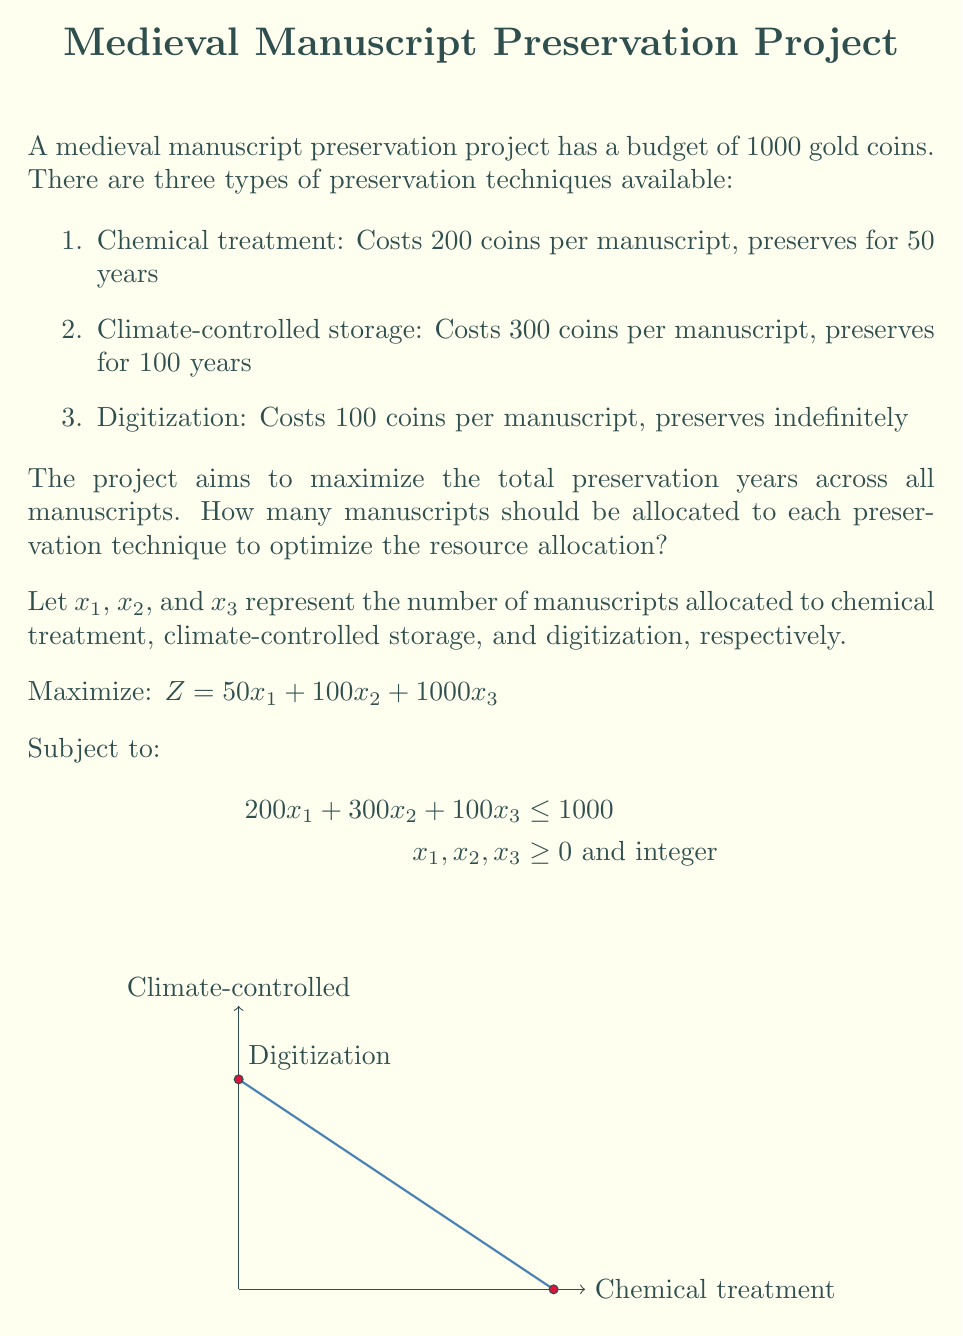Provide a solution to this math problem. To solve this linear programming problem with integer constraints, we can use the graphical method and then round down to the nearest integer solution:

1. Plot the constraint: $200x_1 + 300x_2 + 100x_3 = 1000$

2. The optimal solution will be at one of the extreme points of the feasible region.

3. The extreme points are:
   (0, 0, 10), (5, 0, 0), (0, 3.33, 0)

4. Evaluate the objective function at each point:
   Z(0, 0, 10) = 10,000
   Z(5, 0, 0) = 250
   Z(0, 3.33, 0) = 333

5. The optimal solution is (0, 0, 10), which maximizes the objective function.

6. However, we need integer solutions. Rounding down, we get:
   $x_1 = 0$, $x_2 = 0$, $x_3 = 10$

7. This solution uses exactly 1000 gold coins (10 * 100 = 1000) and provides 10,000 years of preservation.

Therefore, the optimal resource allocation is to digitize 10 manuscripts.
Answer: Digitize 10 manuscripts 